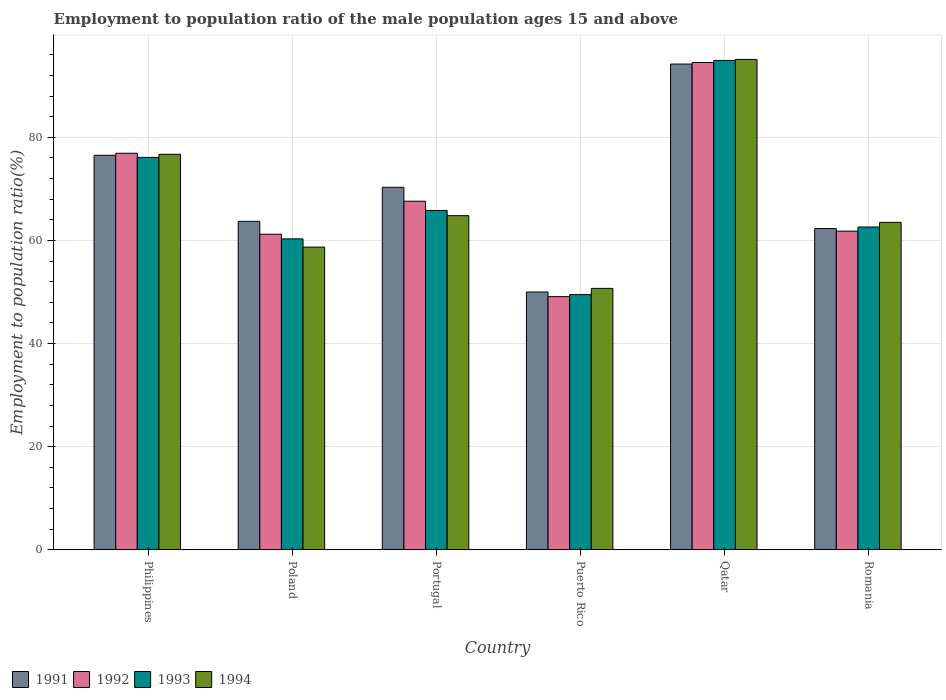How many different coloured bars are there?
Offer a terse response. 4. How many groups of bars are there?
Offer a terse response. 6. How many bars are there on the 1st tick from the right?
Make the answer very short. 4. What is the employment to population ratio in 1993 in Qatar?
Provide a succinct answer. 94.9. Across all countries, what is the maximum employment to population ratio in 1991?
Provide a short and direct response. 94.2. Across all countries, what is the minimum employment to population ratio in 1992?
Your answer should be compact. 49.1. In which country was the employment to population ratio in 1993 maximum?
Provide a succinct answer. Qatar. In which country was the employment to population ratio in 1991 minimum?
Make the answer very short. Puerto Rico. What is the total employment to population ratio in 1991 in the graph?
Your answer should be compact. 417. What is the difference between the employment to population ratio in 1994 in Philippines and that in Portugal?
Make the answer very short. 11.9. What is the difference between the employment to population ratio in 1994 in Philippines and the employment to population ratio in 1993 in Portugal?
Make the answer very short. 10.9. What is the average employment to population ratio in 1993 per country?
Offer a very short reply. 68.2. What is the difference between the employment to population ratio of/in 1991 and employment to population ratio of/in 1994 in Romania?
Ensure brevity in your answer.  -1.2. In how many countries, is the employment to population ratio in 1991 greater than 88 %?
Make the answer very short. 1. What is the ratio of the employment to population ratio in 1992 in Portugal to that in Puerto Rico?
Your response must be concise. 1.38. What is the difference between the highest and the second highest employment to population ratio in 1994?
Your answer should be compact. -11.9. What is the difference between the highest and the lowest employment to population ratio in 1994?
Offer a terse response. 44.4. In how many countries, is the employment to population ratio in 1994 greater than the average employment to population ratio in 1994 taken over all countries?
Make the answer very short. 2. Is the sum of the employment to population ratio in 1994 in Puerto Rico and Romania greater than the maximum employment to population ratio in 1992 across all countries?
Offer a very short reply. Yes. What does the 2nd bar from the left in Portugal represents?
Offer a very short reply. 1992. How many countries are there in the graph?
Provide a short and direct response. 6. What is the difference between two consecutive major ticks on the Y-axis?
Ensure brevity in your answer.  20. What is the title of the graph?
Make the answer very short. Employment to population ratio of the male population ages 15 and above. What is the label or title of the X-axis?
Make the answer very short. Country. What is the Employment to population ratio(%) of 1991 in Philippines?
Provide a short and direct response. 76.5. What is the Employment to population ratio(%) in 1992 in Philippines?
Offer a terse response. 76.9. What is the Employment to population ratio(%) in 1993 in Philippines?
Your answer should be very brief. 76.1. What is the Employment to population ratio(%) of 1994 in Philippines?
Make the answer very short. 76.7. What is the Employment to population ratio(%) of 1991 in Poland?
Provide a succinct answer. 63.7. What is the Employment to population ratio(%) in 1992 in Poland?
Make the answer very short. 61.2. What is the Employment to population ratio(%) of 1993 in Poland?
Your response must be concise. 60.3. What is the Employment to population ratio(%) of 1994 in Poland?
Offer a terse response. 58.7. What is the Employment to population ratio(%) in 1991 in Portugal?
Your answer should be compact. 70.3. What is the Employment to population ratio(%) of 1992 in Portugal?
Make the answer very short. 67.6. What is the Employment to population ratio(%) in 1993 in Portugal?
Make the answer very short. 65.8. What is the Employment to population ratio(%) of 1994 in Portugal?
Keep it short and to the point. 64.8. What is the Employment to population ratio(%) of 1991 in Puerto Rico?
Make the answer very short. 50. What is the Employment to population ratio(%) of 1992 in Puerto Rico?
Your answer should be compact. 49.1. What is the Employment to population ratio(%) in 1993 in Puerto Rico?
Keep it short and to the point. 49.5. What is the Employment to population ratio(%) in 1994 in Puerto Rico?
Your answer should be compact. 50.7. What is the Employment to population ratio(%) in 1991 in Qatar?
Give a very brief answer. 94.2. What is the Employment to population ratio(%) in 1992 in Qatar?
Provide a succinct answer. 94.5. What is the Employment to population ratio(%) in 1993 in Qatar?
Offer a terse response. 94.9. What is the Employment to population ratio(%) of 1994 in Qatar?
Offer a very short reply. 95.1. What is the Employment to population ratio(%) of 1991 in Romania?
Ensure brevity in your answer.  62.3. What is the Employment to population ratio(%) of 1992 in Romania?
Your response must be concise. 61.8. What is the Employment to population ratio(%) of 1993 in Romania?
Offer a very short reply. 62.6. What is the Employment to population ratio(%) in 1994 in Romania?
Provide a succinct answer. 63.5. Across all countries, what is the maximum Employment to population ratio(%) of 1991?
Your answer should be compact. 94.2. Across all countries, what is the maximum Employment to population ratio(%) of 1992?
Give a very brief answer. 94.5. Across all countries, what is the maximum Employment to population ratio(%) of 1993?
Your response must be concise. 94.9. Across all countries, what is the maximum Employment to population ratio(%) of 1994?
Your answer should be very brief. 95.1. Across all countries, what is the minimum Employment to population ratio(%) of 1992?
Provide a short and direct response. 49.1. Across all countries, what is the minimum Employment to population ratio(%) of 1993?
Ensure brevity in your answer.  49.5. Across all countries, what is the minimum Employment to population ratio(%) in 1994?
Make the answer very short. 50.7. What is the total Employment to population ratio(%) in 1991 in the graph?
Provide a short and direct response. 417. What is the total Employment to population ratio(%) of 1992 in the graph?
Your response must be concise. 411.1. What is the total Employment to population ratio(%) of 1993 in the graph?
Provide a short and direct response. 409.2. What is the total Employment to population ratio(%) of 1994 in the graph?
Keep it short and to the point. 409.5. What is the difference between the Employment to population ratio(%) of 1992 in Philippines and that in Poland?
Provide a short and direct response. 15.7. What is the difference between the Employment to population ratio(%) in 1993 in Philippines and that in Poland?
Your answer should be compact. 15.8. What is the difference between the Employment to population ratio(%) in 1993 in Philippines and that in Portugal?
Your answer should be very brief. 10.3. What is the difference between the Employment to population ratio(%) of 1994 in Philippines and that in Portugal?
Your answer should be very brief. 11.9. What is the difference between the Employment to population ratio(%) in 1992 in Philippines and that in Puerto Rico?
Your answer should be very brief. 27.8. What is the difference between the Employment to population ratio(%) in 1993 in Philippines and that in Puerto Rico?
Your answer should be compact. 26.6. What is the difference between the Employment to population ratio(%) of 1994 in Philippines and that in Puerto Rico?
Offer a terse response. 26. What is the difference between the Employment to population ratio(%) of 1991 in Philippines and that in Qatar?
Make the answer very short. -17.7. What is the difference between the Employment to population ratio(%) in 1992 in Philippines and that in Qatar?
Make the answer very short. -17.6. What is the difference between the Employment to population ratio(%) of 1993 in Philippines and that in Qatar?
Ensure brevity in your answer.  -18.8. What is the difference between the Employment to population ratio(%) of 1994 in Philippines and that in Qatar?
Your answer should be compact. -18.4. What is the difference between the Employment to population ratio(%) in 1991 in Philippines and that in Romania?
Keep it short and to the point. 14.2. What is the difference between the Employment to population ratio(%) in 1991 in Poland and that in Puerto Rico?
Offer a terse response. 13.7. What is the difference between the Employment to population ratio(%) in 1994 in Poland and that in Puerto Rico?
Provide a succinct answer. 8. What is the difference between the Employment to population ratio(%) of 1991 in Poland and that in Qatar?
Offer a very short reply. -30.5. What is the difference between the Employment to population ratio(%) in 1992 in Poland and that in Qatar?
Your answer should be compact. -33.3. What is the difference between the Employment to population ratio(%) of 1993 in Poland and that in Qatar?
Keep it short and to the point. -34.6. What is the difference between the Employment to population ratio(%) in 1994 in Poland and that in Qatar?
Your answer should be very brief. -36.4. What is the difference between the Employment to population ratio(%) in 1991 in Poland and that in Romania?
Your answer should be compact. 1.4. What is the difference between the Employment to population ratio(%) in 1992 in Poland and that in Romania?
Keep it short and to the point. -0.6. What is the difference between the Employment to population ratio(%) in 1993 in Poland and that in Romania?
Provide a succinct answer. -2.3. What is the difference between the Employment to population ratio(%) of 1991 in Portugal and that in Puerto Rico?
Your response must be concise. 20.3. What is the difference between the Employment to population ratio(%) in 1992 in Portugal and that in Puerto Rico?
Your answer should be very brief. 18.5. What is the difference between the Employment to population ratio(%) in 1994 in Portugal and that in Puerto Rico?
Give a very brief answer. 14.1. What is the difference between the Employment to population ratio(%) of 1991 in Portugal and that in Qatar?
Provide a short and direct response. -23.9. What is the difference between the Employment to population ratio(%) in 1992 in Portugal and that in Qatar?
Your answer should be compact. -26.9. What is the difference between the Employment to population ratio(%) in 1993 in Portugal and that in Qatar?
Ensure brevity in your answer.  -29.1. What is the difference between the Employment to population ratio(%) in 1994 in Portugal and that in Qatar?
Ensure brevity in your answer.  -30.3. What is the difference between the Employment to population ratio(%) of 1992 in Portugal and that in Romania?
Ensure brevity in your answer.  5.8. What is the difference between the Employment to population ratio(%) of 1993 in Portugal and that in Romania?
Offer a very short reply. 3.2. What is the difference between the Employment to population ratio(%) of 1994 in Portugal and that in Romania?
Your answer should be compact. 1.3. What is the difference between the Employment to population ratio(%) in 1991 in Puerto Rico and that in Qatar?
Keep it short and to the point. -44.2. What is the difference between the Employment to population ratio(%) in 1992 in Puerto Rico and that in Qatar?
Your response must be concise. -45.4. What is the difference between the Employment to population ratio(%) of 1993 in Puerto Rico and that in Qatar?
Provide a succinct answer. -45.4. What is the difference between the Employment to population ratio(%) of 1994 in Puerto Rico and that in Qatar?
Offer a very short reply. -44.4. What is the difference between the Employment to population ratio(%) in 1991 in Puerto Rico and that in Romania?
Your response must be concise. -12.3. What is the difference between the Employment to population ratio(%) of 1992 in Puerto Rico and that in Romania?
Provide a short and direct response. -12.7. What is the difference between the Employment to population ratio(%) in 1993 in Puerto Rico and that in Romania?
Make the answer very short. -13.1. What is the difference between the Employment to population ratio(%) in 1991 in Qatar and that in Romania?
Your answer should be very brief. 31.9. What is the difference between the Employment to population ratio(%) in 1992 in Qatar and that in Romania?
Give a very brief answer. 32.7. What is the difference between the Employment to population ratio(%) in 1993 in Qatar and that in Romania?
Your answer should be very brief. 32.3. What is the difference between the Employment to population ratio(%) in 1994 in Qatar and that in Romania?
Offer a terse response. 31.6. What is the difference between the Employment to population ratio(%) of 1991 in Philippines and the Employment to population ratio(%) of 1994 in Poland?
Provide a short and direct response. 17.8. What is the difference between the Employment to population ratio(%) in 1992 in Philippines and the Employment to population ratio(%) in 1994 in Poland?
Offer a terse response. 18.2. What is the difference between the Employment to population ratio(%) of 1991 in Philippines and the Employment to population ratio(%) of 1993 in Portugal?
Provide a short and direct response. 10.7. What is the difference between the Employment to population ratio(%) in 1991 in Philippines and the Employment to population ratio(%) in 1994 in Portugal?
Offer a very short reply. 11.7. What is the difference between the Employment to population ratio(%) of 1992 in Philippines and the Employment to population ratio(%) of 1993 in Portugal?
Give a very brief answer. 11.1. What is the difference between the Employment to population ratio(%) in 1992 in Philippines and the Employment to population ratio(%) in 1994 in Portugal?
Provide a short and direct response. 12.1. What is the difference between the Employment to population ratio(%) of 1993 in Philippines and the Employment to population ratio(%) of 1994 in Portugal?
Your response must be concise. 11.3. What is the difference between the Employment to population ratio(%) of 1991 in Philippines and the Employment to population ratio(%) of 1992 in Puerto Rico?
Give a very brief answer. 27.4. What is the difference between the Employment to population ratio(%) of 1991 in Philippines and the Employment to population ratio(%) of 1994 in Puerto Rico?
Offer a terse response. 25.8. What is the difference between the Employment to population ratio(%) of 1992 in Philippines and the Employment to population ratio(%) of 1993 in Puerto Rico?
Make the answer very short. 27.4. What is the difference between the Employment to population ratio(%) in 1992 in Philippines and the Employment to population ratio(%) in 1994 in Puerto Rico?
Provide a short and direct response. 26.2. What is the difference between the Employment to population ratio(%) in 1993 in Philippines and the Employment to population ratio(%) in 1994 in Puerto Rico?
Offer a terse response. 25.4. What is the difference between the Employment to population ratio(%) in 1991 in Philippines and the Employment to population ratio(%) in 1993 in Qatar?
Provide a short and direct response. -18.4. What is the difference between the Employment to population ratio(%) in 1991 in Philippines and the Employment to population ratio(%) in 1994 in Qatar?
Provide a short and direct response. -18.6. What is the difference between the Employment to population ratio(%) in 1992 in Philippines and the Employment to population ratio(%) in 1994 in Qatar?
Your response must be concise. -18.2. What is the difference between the Employment to population ratio(%) in 1991 in Philippines and the Employment to population ratio(%) in 1992 in Romania?
Your answer should be very brief. 14.7. What is the difference between the Employment to population ratio(%) in 1991 in Philippines and the Employment to population ratio(%) in 1993 in Romania?
Offer a very short reply. 13.9. What is the difference between the Employment to population ratio(%) in 1993 in Philippines and the Employment to population ratio(%) in 1994 in Romania?
Provide a short and direct response. 12.6. What is the difference between the Employment to population ratio(%) in 1991 in Poland and the Employment to population ratio(%) in 1993 in Portugal?
Your response must be concise. -2.1. What is the difference between the Employment to population ratio(%) of 1991 in Poland and the Employment to population ratio(%) of 1994 in Portugal?
Offer a terse response. -1.1. What is the difference between the Employment to population ratio(%) of 1991 in Poland and the Employment to population ratio(%) of 1992 in Puerto Rico?
Provide a succinct answer. 14.6. What is the difference between the Employment to population ratio(%) in 1991 in Poland and the Employment to population ratio(%) in 1994 in Puerto Rico?
Your answer should be very brief. 13. What is the difference between the Employment to population ratio(%) in 1991 in Poland and the Employment to population ratio(%) in 1992 in Qatar?
Keep it short and to the point. -30.8. What is the difference between the Employment to population ratio(%) in 1991 in Poland and the Employment to population ratio(%) in 1993 in Qatar?
Your answer should be compact. -31.2. What is the difference between the Employment to population ratio(%) of 1991 in Poland and the Employment to population ratio(%) of 1994 in Qatar?
Your answer should be compact. -31.4. What is the difference between the Employment to population ratio(%) of 1992 in Poland and the Employment to population ratio(%) of 1993 in Qatar?
Make the answer very short. -33.7. What is the difference between the Employment to population ratio(%) in 1992 in Poland and the Employment to population ratio(%) in 1994 in Qatar?
Offer a terse response. -33.9. What is the difference between the Employment to population ratio(%) of 1993 in Poland and the Employment to population ratio(%) of 1994 in Qatar?
Ensure brevity in your answer.  -34.8. What is the difference between the Employment to population ratio(%) in 1991 in Poland and the Employment to population ratio(%) in 1994 in Romania?
Keep it short and to the point. 0.2. What is the difference between the Employment to population ratio(%) in 1993 in Poland and the Employment to population ratio(%) in 1994 in Romania?
Offer a terse response. -3.2. What is the difference between the Employment to population ratio(%) of 1991 in Portugal and the Employment to population ratio(%) of 1992 in Puerto Rico?
Offer a very short reply. 21.2. What is the difference between the Employment to population ratio(%) of 1991 in Portugal and the Employment to population ratio(%) of 1993 in Puerto Rico?
Keep it short and to the point. 20.8. What is the difference between the Employment to population ratio(%) of 1991 in Portugal and the Employment to population ratio(%) of 1994 in Puerto Rico?
Ensure brevity in your answer.  19.6. What is the difference between the Employment to population ratio(%) of 1992 in Portugal and the Employment to population ratio(%) of 1993 in Puerto Rico?
Give a very brief answer. 18.1. What is the difference between the Employment to population ratio(%) of 1992 in Portugal and the Employment to population ratio(%) of 1994 in Puerto Rico?
Provide a short and direct response. 16.9. What is the difference between the Employment to population ratio(%) of 1993 in Portugal and the Employment to population ratio(%) of 1994 in Puerto Rico?
Make the answer very short. 15.1. What is the difference between the Employment to population ratio(%) in 1991 in Portugal and the Employment to population ratio(%) in 1992 in Qatar?
Provide a short and direct response. -24.2. What is the difference between the Employment to population ratio(%) in 1991 in Portugal and the Employment to population ratio(%) in 1993 in Qatar?
Offer a very short reply. -24.6. What is the difference between the Employment to population ratio(%) of 1991 in Portugal and the Employment to population ratio(%) of 1994 in Qatar?
Make the answer very short. -24.8. What is the difference between the Employment to population ratio(%) of 1992 in Portugal and the Employment to population ratio(%) of 1993 in Qatar?
Offer a terse response. -27.3. What is the difference between the Employment to population ratio(%) of 1992 in Portugal and the Employment to population ratio(%) of 1994 in Qatar?
Make the answer very short. -27.5. What is the difference between the Employment to population ratio(%) of 1993 in Portugal and the Employment to population ratio(%) of 1994 in Qatar?
Offer a terse response. -29.3. What is the difference between the Employment to population ratio(%) in 1991 in Portugal and the Employment to population ratio(%) in 1993 in Romania?
Give a very brief answer. 7.7. What is the difference between the Employment to population ratio(%) in 1991 in Portugal and the Employment to population ratio(%) in 1994 in Romania?
Keep it short and to the point. 6.8. What is the difference between the Employment to population ratio(%) in 1992 in Portugal and the Employment to population ratio(%) in 1994 in Romania?
Your answer should be compact. 4.1. What is the difference between the Employment to population ratio(%) of 1993 in Portugal and the Employment to population ratio(%) of 1994 in Romania?
Make the answer very short. 2.3. What is the difference between the Employment to population ratio(%) in 1991 in Puerto Rico and the Employment to population ratio(%) in 1992 in Qatar?
Keep it short and to the point. -44.5. What is the difference between the Employment to population ratio(%) of 1991 in Puerto Rico and the Employment to population ratio(%) of 1993 in Qatar?
Make the answer very short. -44.9. What is the difference between the Employment to population ratio(%) in 1991 in Puerto Rico and the Employment to population ratio(%) in 1994 in Qatar?
Give a very brief answer. -45.1. What is the difference between the Employment to population ratio(%) of 1992 in Puerto Rico and the Employment to population ratio(%) of 1993 in Qatar?
Provide a short and direct response. -45.8. What is the difference between the Employment to population ratio(%) in 1992 in Puerto Rico and the Employment to population ratio(%) in 1994 in Qatar?
Your answer should be very brief. -46. What is the difference between the Employment to population ratio(%) of 1993 in Puerto Rico and the Employment to population ratio(%) of 1994 in Qatar?
Offer a terse response. -45.6. What is the difference between the Employment to population ratio(%) of 1991 in Puerto Rico and the Employment to population ratio(%) of 1994 in Romania?
Your response must be concise. -13.5. What is the difference between the Employment to population ratio(%) of 1992 in Puerto Rico and the Employment to population ratio(%) of 1994 in Romania?
Ensure brevity in your answer.  -14.4. What is the difference between the Employment to population ratio(%) of 1991 in Qatar and the Employment to population ratio(%) of 1992 in Romania?
Make the answer very short. 32.4. What is the difference between the Employment to population ratio(%) in 1991 in Qatar and the Employment to population ratio(%) in 1993 in Romania?
Your answer should be compact. 31.6. What is the difference between the Employment to population ratio(%) in 1991 in Qatar and the Employment to population ratio(%) in 1994 in Romania?
Your response must be concise. 30.7. What is the difference between the Employment to population ratio(%) of 1992 in Qatar and the Employment to population ratio(%) of 1993 in Romania?
Provide a succinct answer. 31.9. What is the difference between the Employment to population ratio(%) in 1993 in Qatar and the Employment to population ratio(%) in 1994 in Romania?
Provide a succinct answer. 31.4. What is the average Employment to population ratio(%) in 1991 per country?
Offer a very short reply. 69.5. What is the average Employment to population ratio(%) of 1992 per country?
Your answer should be very brief. 68.52. What is the average Employment to population ratio(%) of 1993 per country?
Offer a very short reply. 68.2. What is the average Employment to population ratio(%) of 1994 per country?
Provide a short and direct response. 68.25. What is the difference between the Employment to population ratio(%) in 1991 and Employment to population ratio(%) in 1994 in Philippines?
Offer a very short reply. -0.2. What is the difference between the Employment to population ratio(%) of 1992 and Employment to population ratio(%) of 1993 in Philippines?
Offer a terse response. 0.8. What is the difference between the Employment to population ratio(%) of 1991 and Employment to population ratio(%) of 1993 in Poland?
Offer a terse response. 3.4. What is the difference between the Employment to population ratio(%) in 1991 and Employment to population ratio(%) in 1993 in Portugal?
Keep it short and to the point. 4.5. What is the difference between the Employment to population ratio(%) of 1991 and Employment to population ratio(%) of 1994 in Portugal?
Your response must be concise. 5.5. What is the difference between the Employment to population ratio(%) of 1992 and Employment to population ratio(%) of 1994 in Portugal?
Your response must be concise. 2.8. What is the difference between the Employment to population ratio(%) in 1993 and Employment to population ratio(%) in 1994 in Portugal?
Ensure brevity in your answer.  1. What is the difference between the Employment to population ratio(%) of 1991 and Employment to population ratio(%) of 1992 in Puerto Rico?
Give a very brief answer. 0.9. What is the difference between the Employment to population ratio(%) of 1991 and Employment to population ratio(%) of 1993 in Puerto Rico?
Your answer should be very brief. 0.5. What is the difference between the Employment to population ratio(%) in 1991 and Employment to population ratio(%) in 1994 in Puerto Rico?
Your answer should be compact. -0.7. What is the difference between the Employment to population ratio(%) in 1991 and Employment to population ratio(%) in 1992 in Qatar?
Provide a succinct answer. -0.3. What is the difference between the Employment to population ratio(%) of 1991 and Employment to population ratio(%) of 1994 in Qatar?
Your answer should be compact. -0.9. What is the difference between the Employment to population ratio(%) in 1993 and Employment to population ratio(%) in 1994 in Qatar?
Your answer should be very brief. -0.2. What is the difference between the Employment to population ratio(%) of 1991 and Employment to population ratio(%) of 1993 in Romania?
Your response must be concise. -0.3. What is the difference between the Employment to population ratio(%) in 1991 and Employment to population ratio(%) in 1994 in Romania?
Offer a terse response. -1.2. What is the ratio of the Employment to population ratio(%) of 1991 in Philippines to that in Poland?
Make the answer very short. 1.2. What is the ratio of the Employment to population ratio(%) in 1992 in Philippines to that in Poland?
Your response must be concise. 1.26. What is the ratio of the Employment to population ratio(%) of 1993 in Philippines to that in Poland?
Ensure brevity in your answer.  1.26. What is the ratio of the Employment to population ratio(%) of 1994 in Philippines to that in Poland?
Provide a succinct answer. 1.31. What is the ratio of the Employment to population ratio(%) in 1991 in Philippines to that in Portugal?
Offer a very short reply. 1.09. What is the ratio of the Employment to population ratio(%) in 1992 in Philippines to that in Portugal?
Keep it short and to the point. 1.14. What is the ratio of the Employment to population ratio(%) of 1993 in Philippines to that in Portugal?
Make the answer very short. 1.16. What is the ratio of the Employment to population ratio(%) of 1994 in Philippines to that in Portugal?
Keep it short and to the point. 1.18. What is the ratio of the Employment to population ratio(%) of 1991 in Philippines to that in Puerto Rico?
Your response must be concise. 1.53. What is the ratio of the Employment to population ratio(%) in 1992 in Philippines to that in Puerto Rico?
Your answer should be very brief. 1.57. What is the ratio of the Employment to population ratio(%) of 1993 in Philippines to that in Puerto Rico?
Keep it short and to the point. 1.54. What is the ratio of the Employment to population ratio(%) in 1994 in Philippines to that in Puerto Rico?
Offer a terse response. 1.51. What is the ratio of the Employment to population ratio(%) in 1991 in Philippines to that in Qatar?
Offer a terse response. 0.81. What is the ratio of the Employment to population ratio(%) of 1992 in Philippines to that in Qatar?
Make the answer very short. 0.81. What is the ratio of the Employment to population ratio(%) in 1993 in Philippines to that in Qatar?
Your answer should be very brief. 0.8. What is the ratio of the Employment to population ratio(%) in 1994 in Philippines to that in Qatar?
Keep it short and to the point. 0.81. What is the ratio of the Employment to population ratio(%) in 1991 in Philippines to that in Romania?
Ensure brevity in your answer.  1.23. What is the ratio of the Employment to population ratio(%) in 1992 in Philippines to that in Romania?
Offer a terse response. 1.24. What is the ratio of the Employment to population ratio(%) in 1993 in Philippines to that in Romania?
Keep it short and to the point. 1.22. What is the ratio of the Employment to population ratio(%) in 1994 in Philippines to that in Romania?
Your answer should be very brief. 1.21. What is the ratio of the Employment to population ratio(%) of 1991 in Poland to that in Portugal?
Keep it short and to the point. 0.91. What is the ratio of the Employment to population ratio(%) in 1992 in Poland to that in Portugal?
Give a very brief answer. 0.91. What is the ratio of the Employment to population ratio(%) of 1993 in Poland to that in Portugal?
Ensure brevity in your answer.  0.92. What is the ratio of the Employment to population ratio(%) in 1994 in Poland to that in Portugal?
Ensure brevity in your answer.  0.91. What is the ratio of the Employment to population ratio(%) in 1991 in Poland to that in Puerto Rico?
Provide a short and direct response. 1.27. What is the ratio of the Employment to population ratio(%) of 1992 in Poland to that in Puerto Rico?
Your answer should be very brief. 1.25. What is the ratio of the Employment to population ratio(%) of 1993 in Poland to that in Puerto Rico?
Offer a very short reply. 1.22. What is the ratio of the Employment to population ratio(%) of 1994 in Poland to that in Puerto Rico?
Give a very brief answer. 1.16. What is the ratio of the Employment to population ratio(%) in 1991 in Poland to that in Qatar?
Your response must be concise. 0.68. What is the ratio of the Employment to population ratio(%) in 1992 in Poland to that in Qatar?
Give a very brief answer. 0.65. What is the ratio of the Employment to population ratio(%) in 1993 in Poland to that in Qatar?
Your answer should be very brief. 0.64. What is the ratio of the Employment to population ratio(%) of 1994 in Poland to that in Qatar?
Offer a very short reply. 0.62. What is the ratio of the Employment to population ratio(%) of 1991 in Poland to that in Romania?
Your response must be concise. 1.02. What is the ratio of the Employment to population ratio(%) in 1992 in Poland to that in Romania?
Ensure brevity in your answer.  0.99. What is the ratio of the Employment to population ratio(%) of 1993 in Poland to that in Romania?
Provide a succinct answer. 0.96. What is the ratio of the Employment to population ratio(%) of 1994 in Poland to that in Romania?
Your answer should be very brief. 0.92. What is the ratio of the Employment to population ratio(%) of 1991 in Portugal to that in Puerto Rico?
Keep it short and to the point. 1.41. What is the ratio of the Employment to population ratio(%) of 1992 in Portugal to that in Puerto Rico?
Your answer should be very brief. 1.38. What is the ratio of the Employment to population ratio(%) of 1993 in Portugal to that in Puerto Rico?
Your response must be concise. 1.33. What is the ratio of the Employment to population ratio(%) in 1994 in Portugal to that in Puerto Rico?
Your response must be concise. 1.28. What is the ratio of the Employment to population ratio(%) of 1991 in Portugal to that in Qatar?
Your response must be concise. 0.75. What is the ratio of the Employment to population ratio(%) of 1992 in Portugal to that in Qatar?
Ensure brevity in your answer.  0.72. What is the ratio of the Employment to population ratio(%) of 1993 in Portugal to that in Qatar?
Provide a succinct answer. 0.69. What is the ratio of the Employment to population ratio(%) in 1994 in Portugal to that in Qatar?
Your answer should be compact. 0.68. What is the ratio of the Employment to population ratio(%) in 1991 in Portugal to that in Romania?
Your answer should be very brief. 1.13. What is the ratio of the Employment to population ratio(%) in 1992 in Portugal to that in Romania?
Ensure brevity in your answer.  1.09. What is the ratio of the Employment to population ratio(%) of 1993 in Portugal to that in Romania?
Your answer should be compact. 1.05. What is the ratio of the Employment to population ratio(%) in 1994 in Portugal to that in Romania?
Your answer should be compact. 1.02. What is the ratio of the Employment to population ratio(%) in 1991 in Puerto Rico to that in Qatar?
Make the answer very short. 0.53. What is the ratio of the Employment to population ratio(%) in 1992 in Puerto Rico to that in Qatar?
Ensure brevity in your answer.  0.52. What is the ratio of the Employment to population ratio(%) in 1993 in Puerto Rico to that in Qatar?
Provide a short and direct response. 0.52. What is the ratio of the Employment to population ratio(%) in 1994 in Puerto Rico to that in Qatar?
Ensure brevity in your answer.  0.53. What is the ratio of the Employment to population ratio(%) in 1991 in Puerto Rico to that in Romania?
Keep it short and to the point. 0.8. What is the ratio of the Employment to population ratio(%) in 1992 in Puerto Rico to that in Romania?
Provide a short and direct response. 0.79. What is the ratio of the Employment to population ratio(%) of 1993 in Puerto Rico to that in Romania?
Offer a terse response. 0.79. What is the ratio of the Employment to population ratio(%) of 1994 in Puerto Rico to that in Romania?
Provide a succinct answer. 0.8. What is the ratio of the Employment to population ratio(%) of 1991 in Qatar to that in Romania?
Your answer should be compact. 1.51. What is the ratio of the Employment to population ratio(%) of 1992 in Qatar to that in Romania?
Keep it short and to the point. 1.53. What is the ratio of the Employment to population ratio(%) of 1993 in Qatar to that in Romania?
Ensure brevity in your answer.  1.52. What is the ratio of the Employment to population ratio(%) in 1994 in Qatar to that in Romania?
Provide a succinct answer. 1.5. What is the difference between the highest and the second highest Employment to population ratio(%) of 1992?
Provide a succinct answer. 17.6. What is the difference between the highest and the second highest Employment to population ratio(%) of 1994?
Your answer should be very brief. 18.4. What is the difference between the highest and the lowest Employment to population ratio(%) of 1991?
Offer a very short reply. 44.2. What is the difference between the highest and the lowest Employment to population ratio(%) of 1992?
Your response must be concise. 45.4. What is the difference between the highest and the lowest Employment to population ratio(%) of 1993?
Provide a succinct answer. 45.4. What is the difference between the highest and the lowest Employment to population ratio(%) in 1994?
Make the answer very short. 44.4. 